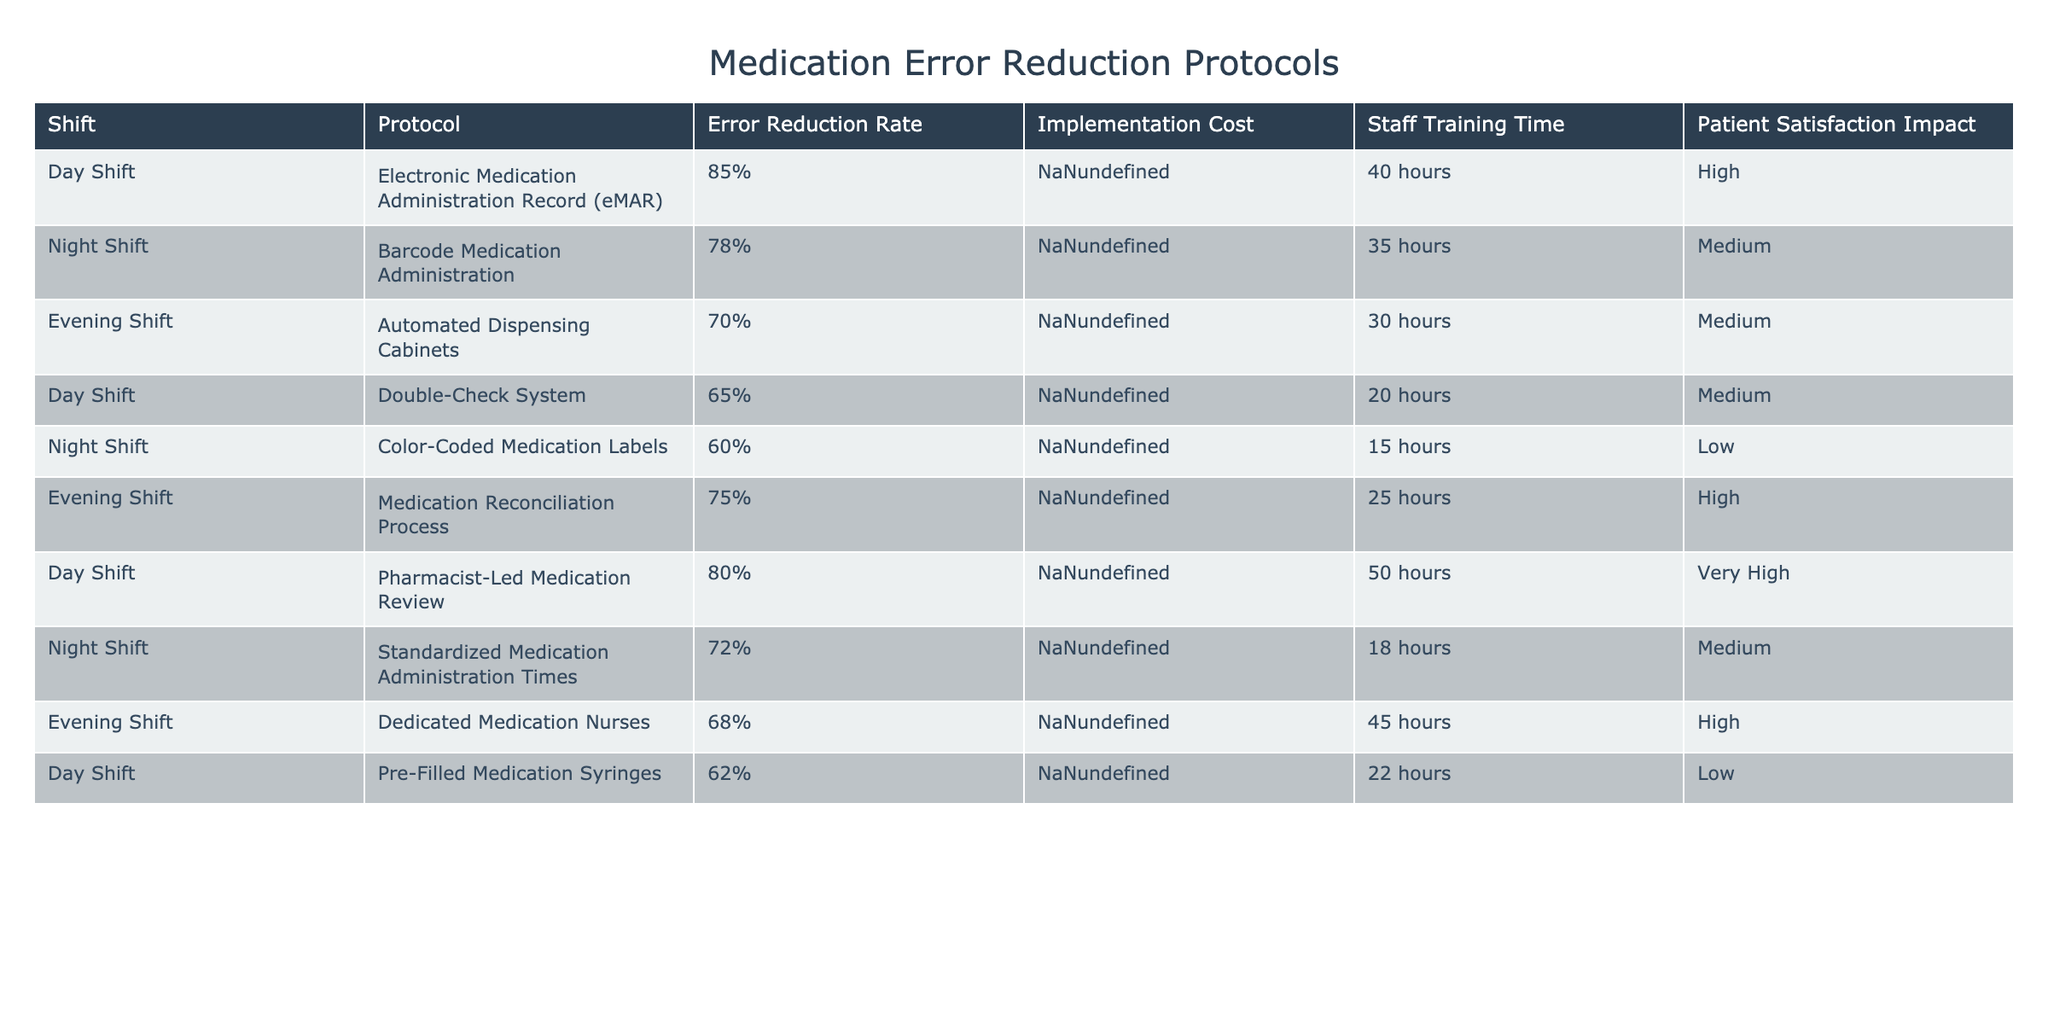What is the error reduction rate for the Night Shift using the Barcode Medication Administration protocol? The Night Shift protocol listed is "Barcode Medication Administration," which has an error reduction rate of 78%.
Answer: 78% Which protocol has the lowest implementation cost? The implementation costs listed for each protocol show that "Color-Coded Medication Labels" has the lowest cost at $3000.
Answer: $3000 What is the average error reduction rate across all shifts? To find the average, sum the error reduction rates: (85 + 78 + 70 + 65 + 60 + 75 + 80 + 72 + 68 + 62) = 750. Then divide by the number of protocols (10): 750 / 10 = 75.
Answer: 75% Is the implementation cost for the Automated Dispensing Cabinets higher than that for the Double-Check System? The implementation cost for the Automated Dispensing Cabinets is $35000, while for the Double-Check System it's $5000. Since $35000 is greater than $5000, the statement is true.
Answer: True Which shift has the highest patient satisfaction impact? The Day Shift protocol "Pharmacist-Led Medication Review" has the highest patient satisfaction impact rated as "Very High."
Answer: Very High If we compare the error reduction rates, which is more effective: the Night Shift's Standardized Medication Administration Times or the Evening Shift's Medication Reconciliation Process? The error reduction rate for the Night Shift's Standardized Medication Administration Times is 72%, whereas for the Evening Shift's Medication Reconciliation Process it is 75%. Since 75% is greater than 72%, the Evening Shift's protocol is more effective.
Answer: Evening Shift's Medication Reconciliation Process What is the total staff training time for the Day Shift protocols? The training times for Day Shift protocols are 40 hours, 20 hours, 50 hours, and 22 hours. Summing these gives: 40 + 20 + 50 + 22 = 132 hours.
Answer: 132 hours Are there any Evening Shift protocols with a high patient satisfaction impact? The table lists one Evening Shift protocol, which is the Medication Reconciliation Process, and it has a patient satisfaction impact of "High." Therefore, there is at least one Evening Shift protocol with high impact.
Answer: Yes Which protocol would be the most cost-effective for the Day Shift based on implementation cost and error reduction rate? The Day Shift's Double-Check System at $5000 has an error reduction rate of 65%, while the eMAR protocol at $25000 has a higher error reduction rate of 85%. Despite the lower cost of the Double-Check System, the eMAR may be considered more cost-effective if error reduction is prioritized.
Answer: eMAR is more cost-effective based on error reduction 